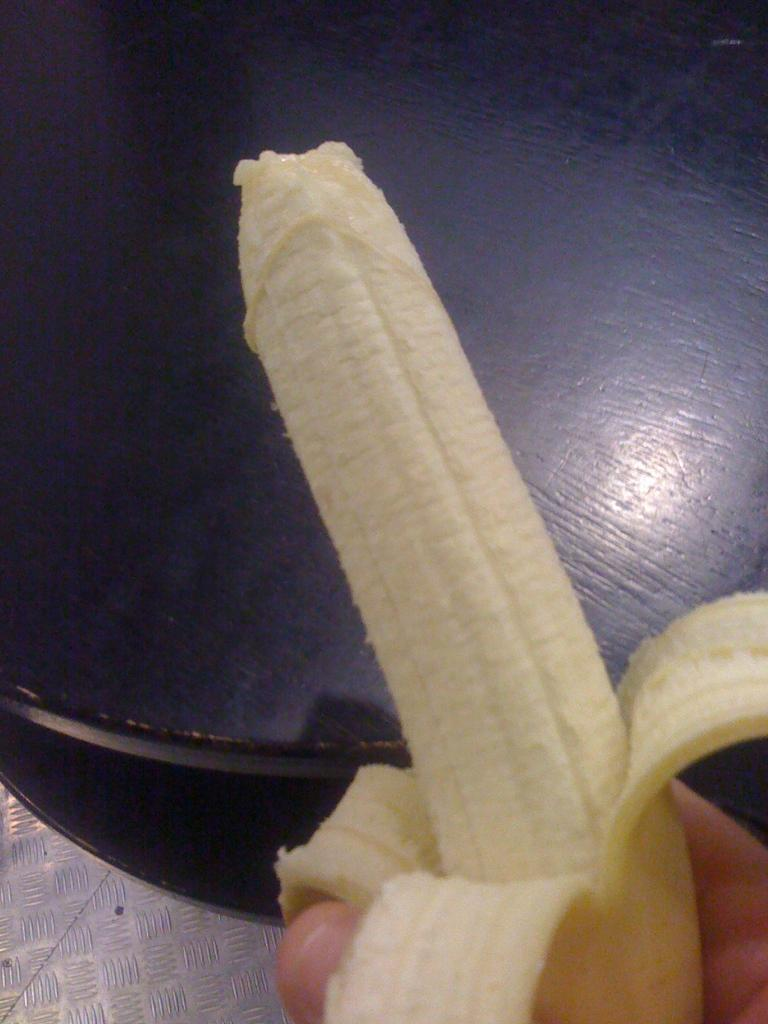What is the person holding in the image? There is a person's hand holding a banana in the image. Where is the hand located in relation to the image? The hand is at the bottom of the image. What type of furniture is present in the image? There is a table placed on the floor in the image. Where is the table located in relation to the image? The table is at the top of the image. How many brothers are visible in the image? There are no brothers present in the image. What channel is the person watching while holding the banana? There is no television or channel visible in the image; it only shows a hand holding a banana and a table. Is there a yak in the image? No, there is no yak present in the image. 